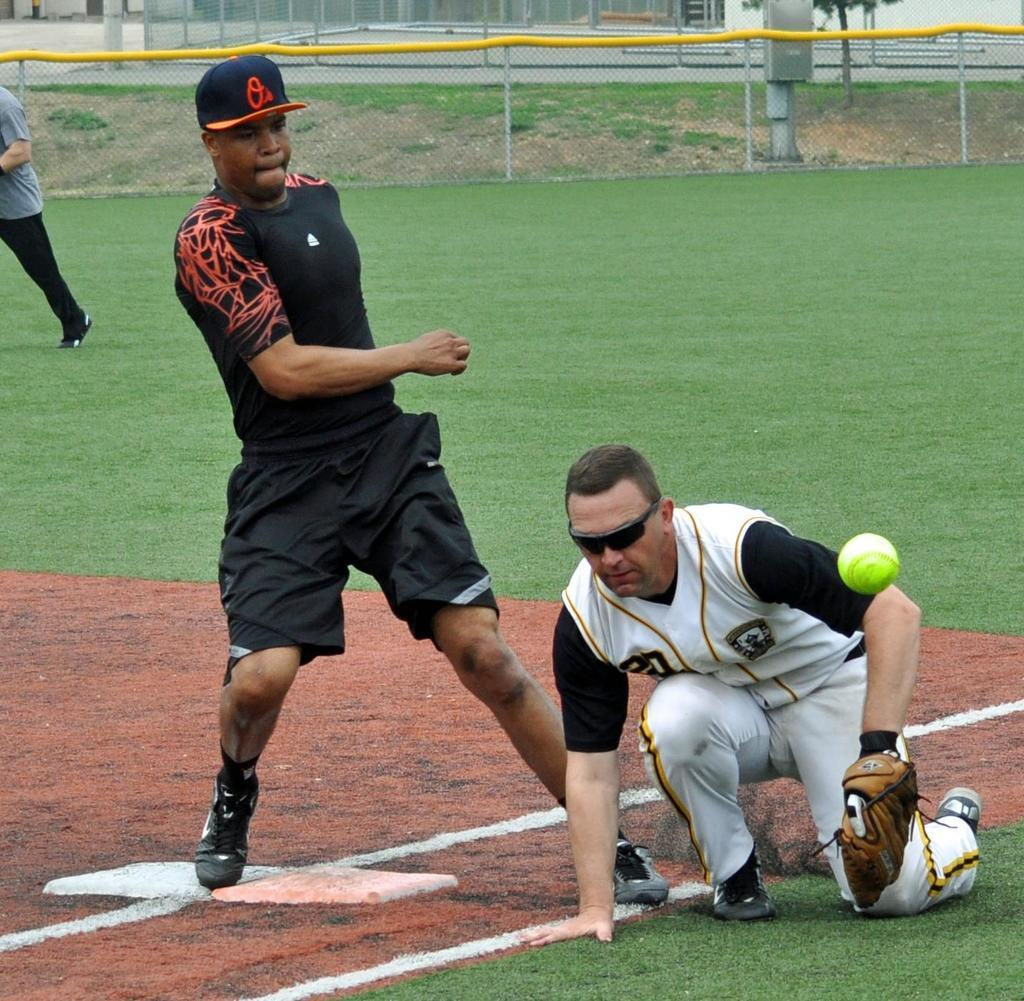What are the people in the image doing? The people in the image are playing. Where are the people playing? The people are playing on the grass. What object can be seen in the image that is commonly used in games? There is a ball visible in the image. What is surrounding the area where people are playing? There is a fence around the area where people are playing. Can you see any clover growing on the grass where the people are playing? There is no mention of clover in the image, so it cannot be determined if it is present or not. Is there a dog playing with the people in the image? There is no dog visible in the image; only people and a ball are present. 